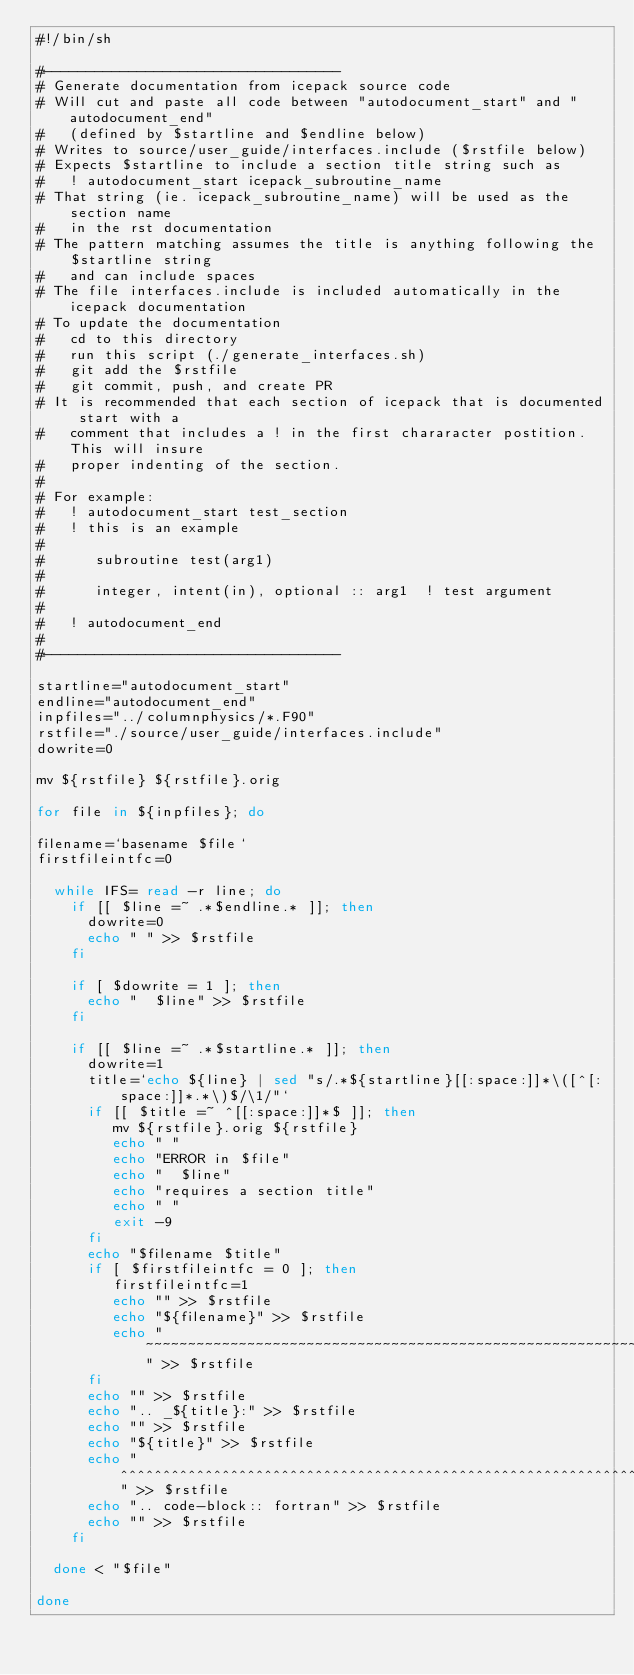<code> <loc_0><loc_0><loc_500><loc_500><_Bash_>#!/bin/sh

#-----------------------------------
# Generate documentation from icepack source code
# Will cut and paste all code between "autodocument_start" and "autodocument_end"
#   (defined by $startline and $endline below)
# Writes to source/user_guide/interfaces.include ($rstfile below)
# Expects $startline to include a section title string such as
#   ! autodocument_start icepack_subroutine_name
# That string (ie. icepack_subroutine_name) will be used as the section name 
#   in the rst documentation
# The pattern matching assumes the title is anything following the $startline string
#   and can include spaces
# The file interfaces.include is included automatically in the icepack documentation
# To update the documentation
#   cd to this directory
#   run this script (./generate_interfaces.sh)
#   git add the $rstfile
#   git commit, push, and create PR
# It is recommended that each section of icepack that is documented start with a
#   comment that includes a ! in the first chararacter postition.  This will insure
#   proper indenting of the section.
#
# For example:
#   ! autodocument_start test_section
#   ! this is an example
#
#      subroutine test(arg1)
#
#      integer, intent(in), optional :: arg1  ! test argument
#
#   ! autodocument_end
#
#-----------------------------------

startline="autodocument_start"
endline="autodocument_end"
inpfiles="../columnphysics/*.F90"
rstfile="./source/user_guide/interfaces.include"
dowrite=0

mv ${rstfile} ${rstfile}.orig

for file in ${inpfiles}; do

filename=`basename $file`
firstfileintfc=0

  while IFS= read -r line; do
    if [[ $line =~ .*$endline.* ]]; then
      dowrite=0
      echo " " >> $rstfile
    fi

    if [ $dowrite = 1 ]; then
      echo "  $line" >> $rstfile
    fi

    if [[ $line =~ .*$startline.* ]]; then
      dowrite=1
      title=`echo ${line} | sed "s/.*${startline}[[:space:]]*\([^[:space:]]*.*\)$/\1/"`
      if [[ $title =~ ^[[:space:]]*$ ]]; then
         mv ${rstfile}.orig ${rstfile}
         echo " "
         echo "ERROR in $file"
         echo "  $line"
         echo "requires a section title"
         echo " "
         exit -9
      fi
      echo "$filename $title"
      if [ $firstfileintfc = 0 ]; then
         firstfileintfc=1
         echo "" >> $rstfile
         echo "${filename}" >> $rstfile
         echo "~~~~~~~~~~~~~~~~~~~~~~~~~~~~~~~~~~~~~~~~~~~~~~~~~~~~~~~~~~" >> $rstfile
      fi
      echo "" >> $rstfile
      echo ".. _${title}:" >> $rstfile
      echo "" >> $rstfile
      echo "${title}" >> $rstfile
      echo "^^^^^^^^^^^^^^^^^^^^^^^^^^^^^^^^^^^^^^^^^^^^^^^^^^^^^^^^^^^^^^" >> $rstfile
      echo ".. code-block:: fortran" >> $rstfile
      echo "" >> $rstfile
    fi

  done < "$file"

done

</code> 